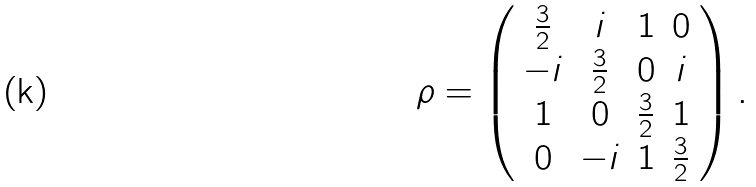Convert formula to latex. <formula><loc_0><loc_0><loc_500><loc_500>\rho = \left ( \begin{array} { c c c c } \frac { 3 } { 2 } & i & 1 & 0 \\ - i & \frac { 3 } { 2 } & 0 & i \\ 1 & 0 & \frac { 3 } { 2 } & 1 \\ 0 & - i & 1 & \frac { 3 } { 2 } \\ \end{array} \right ) .</formula> 